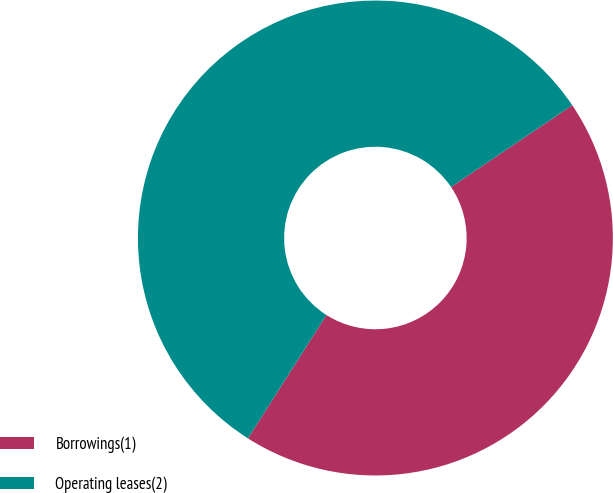Convert chart to OTSL. <chart><loc_0><loc_0><loc_500><loc_500><pie_chart><fcel>Borrowings(1)<fcel>Operating leases(2)<nl><fcel>43.46%<fcel>56.54%<nl></chart> 